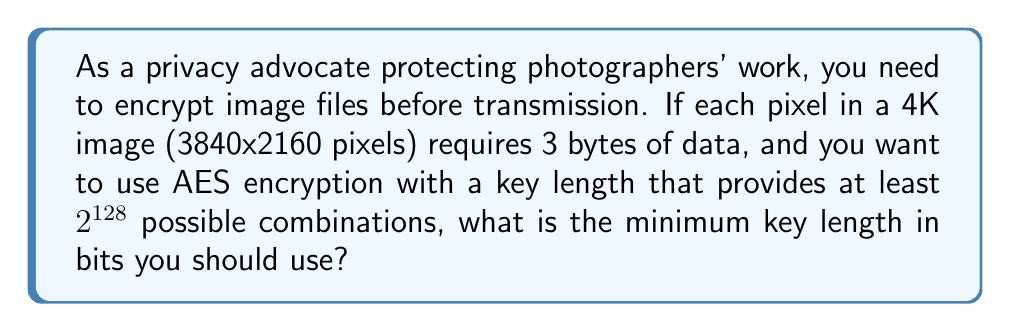Help me with this question. Let's approach this step-by-step:

1) First, we need to calculate the total number of bytes in the image:
   $$ \text{Total bytes} = 3840 \times 2160 \times 3 = 24,883,200 \text{ bytes} $$

2) Now, we need to determine the key length that provides at least $2^{128}$ possible combinations. In cryptography, the key length is directly related to the number of possible combinations.

3) AES supports key lengths of 128, 192, and 256 bits. Let's check each:

   - 128-bit key: $2^{128}$ combinations
   - 192-bit key: $2^{192}$ combinations
   - 256-bit key: $2^{256}$ combinations

4) The question asks for at least $2^{128}$ combinations, so the minimum key length that satisfies this requirement is 128 bits.

5) It's worth noting that while 128 bits meets the minimum requirement, in practice, for highly sensitive data like copyrighted images, you might want to use a longer key length for future-proofing against potential advances in computing power.
Answer: The minimum key length you should use is 128 bits. 